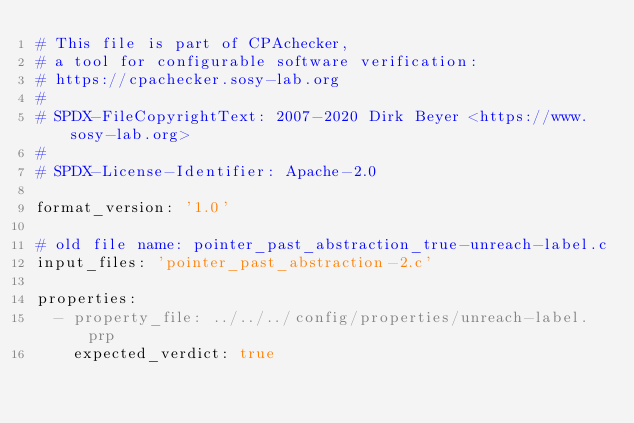Convert code to text. <code><loc_0><loc_0><loc_500><loc_500><_YAML_># This file is part of CPAchecker,
# a tool for configurable software verification:
# https://cpachecker.sosy-lab.org
#
# SPDX-FileCopyrightText: 2007-2020 Dirk Beyer <https://www.sosy-lab.org>
#
# SPDX-License-Identifier: Apache-2.0

format_version: '1.0'

# old file name: pointer_past_abstraction_true-unreach-label.c
input_files: 'pointer_past_abstraction-2.c'

properties:
  - property_file: ../../../config/properties/unreach-label.prp
    expected_verdict: true
</code> 